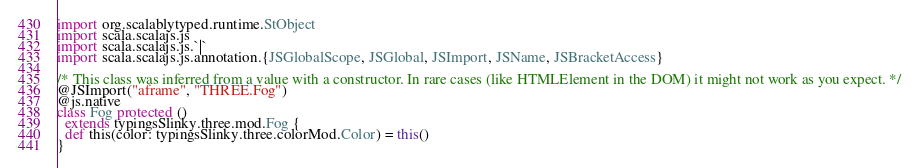<code> <loc_0><loc_0><loc_500><loc_500><_Scala_>
import org.scalablytyped.runtime.StObject
import scala.scalajs.js
import scala.scalajs.js.`|`
import scala.scalajs.js.annotation.{JSGlobalScope, JSGlobal, JSImport, JSName, JSBracketAccess}

/* This class was inferred from a value with a constructor. In rare cases (like HTMLElement in the DOM) it might not work as you expect. */
@JSImport("aframe", "THREE.Fog")
@js.native
class Fog protected ()
  extends typingsSlinky.three.mod.Fog {
  def this(color: typingsSlinky.three.colorMod.Color) = this()
}
</code> 